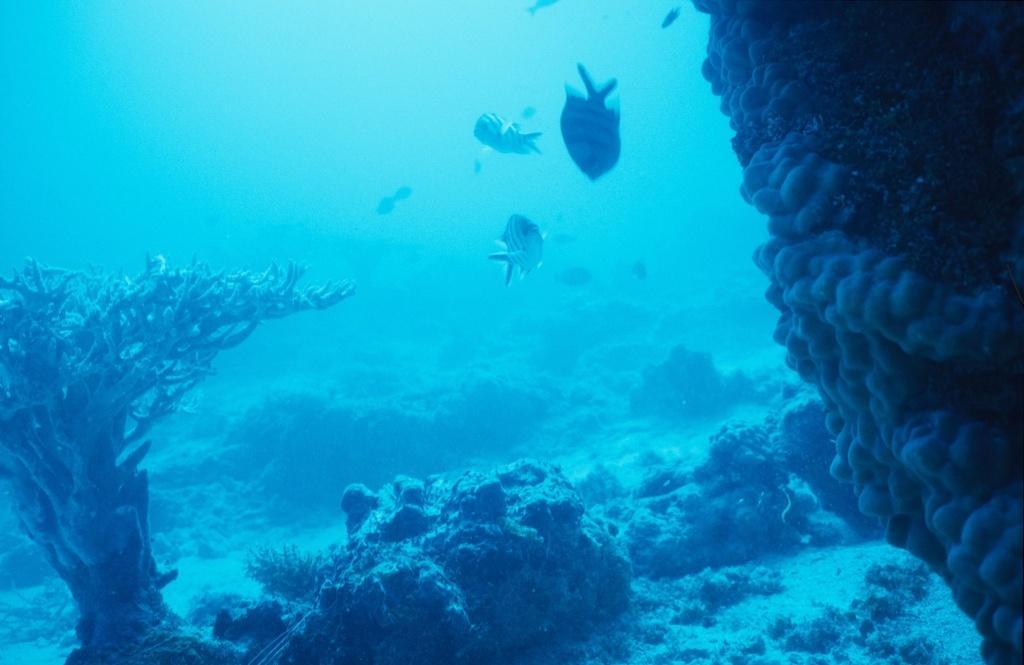In one or two sentences, can you explain what this image depicts? The picture is taken inside the water. On the foreground there are coral reefs and water plant. In the center of the picture there are fishes. 